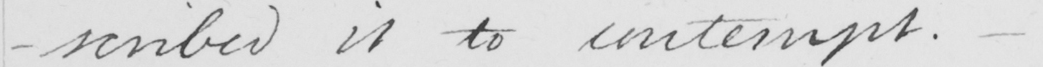Transcribe the text shown in this historical manuscript line. -scribed it to contempt .  _ 